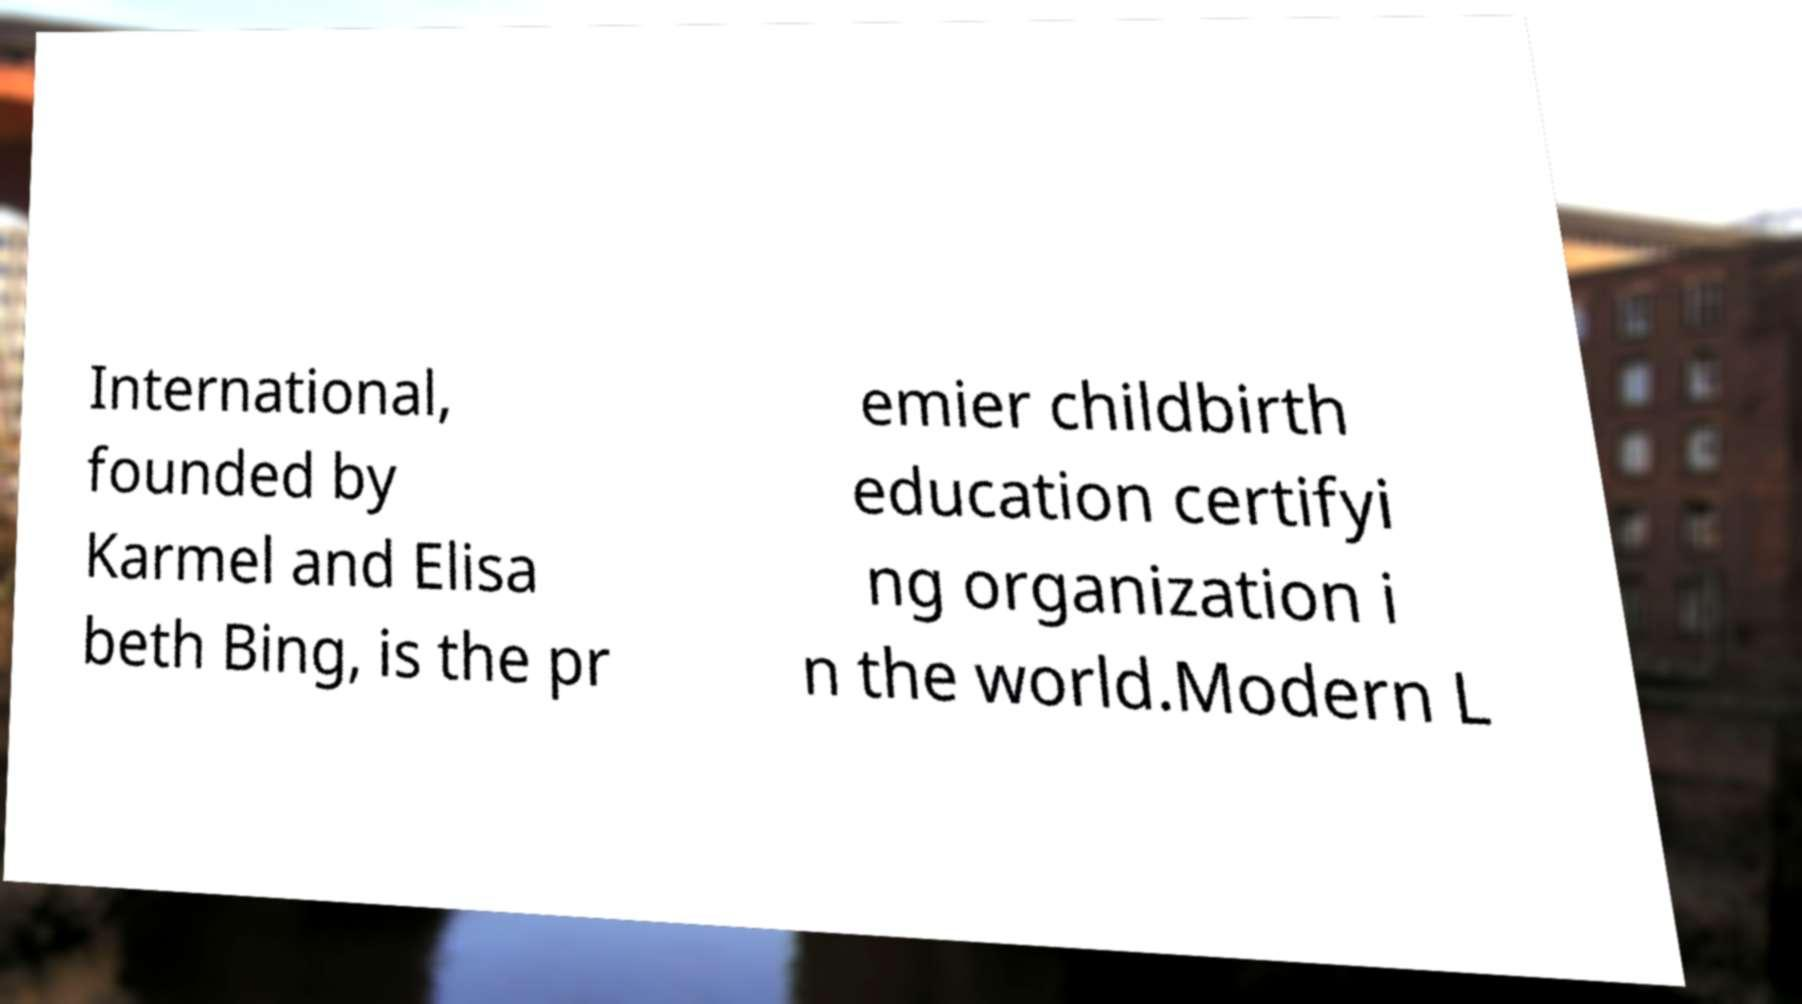I need the written content from this picture converted into text. Can you do that? International, founded by Karmel and Elisa beth Bing, is the pr emier childbirth education certifyi ng organization i n the world.Modern L 